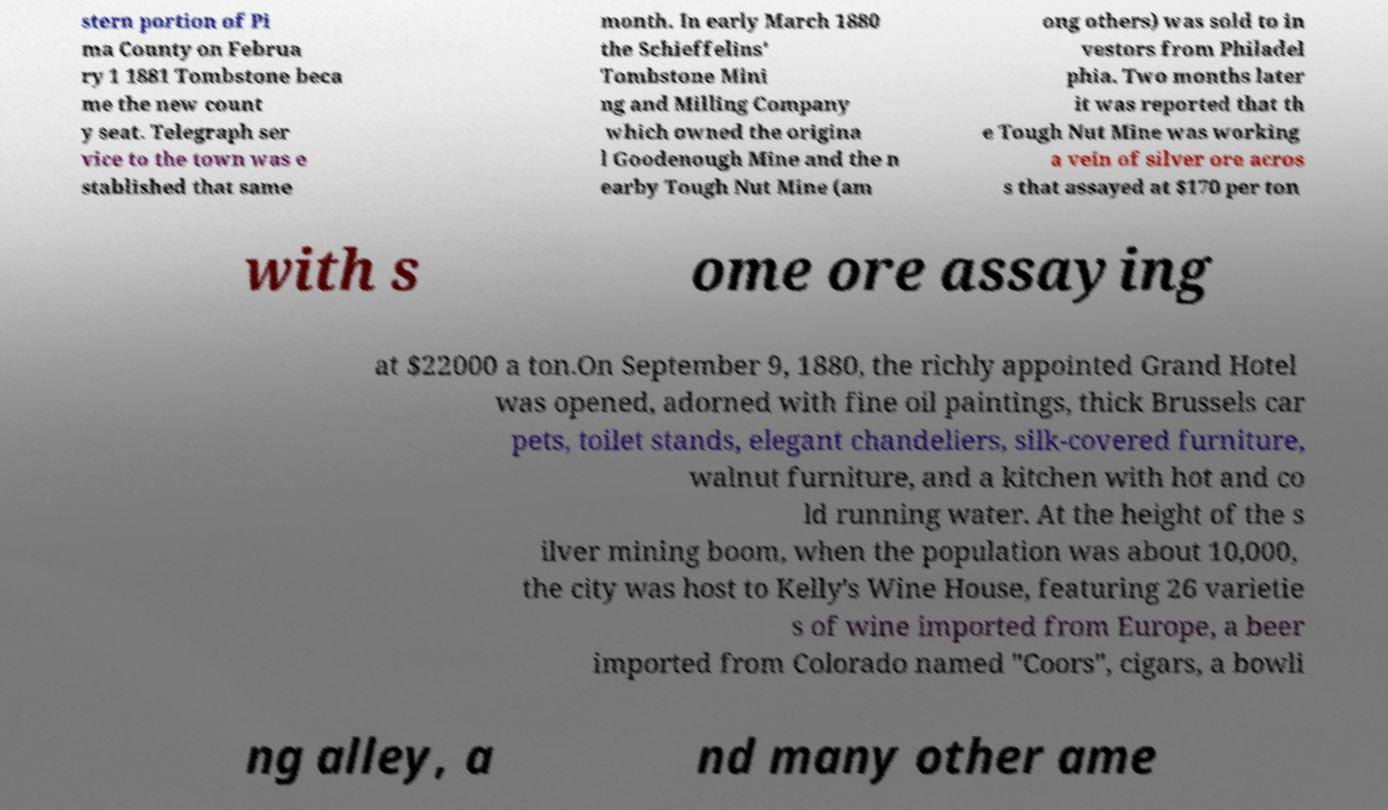For documentation purposes, I need the text within this image transcribed. Could you provide that? stern portion of Pi ma County on Februa ry 1 1881 Tombstone beca me the new count y seat. Telegraph ser vice to the town was e stablished that same month. In early March 1880 the Schieffelins' Tombstone Mini ng and Milling Company which owned the origina l Goodenough Mine and the n earby Tough Nut Mine (am ong others) was sold to in vestors from Philadel phia. Two months later it was reported that th e Tough Nut Mine was working a vein of silver ore acros s that assayed at $170 per ton with s ome ore assaying at $22000 a ton.On September 9, 1880, the richly appointed Grand Hotel was opened, adorned with fine oil paintings, thick Brussels car pets, toilet stands, elegant chandeliers, silk-covered furniture, walnut furniture, and a kitchen with hot and co ld running water. At the height of the s ilver mining boom, when the population was about 10,000, the city was host to Kelly's Wine House, featuring 26 varietie s of wine imported from Europe, a beer imported from Colorado named "Coors", cigars, a bowli ng alley, a nd many other ame 